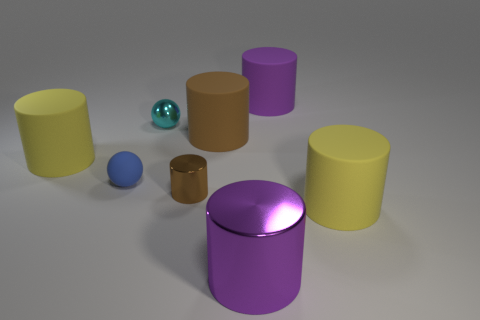Subtract 3 cylinders. How many cylinders are left? 3 Subtract all yellow cylinders. How many cylinders are left? 4 Subtract all brown matte cylinders. How many cylinders are left? 5 Subtract all gray cylinders. Subtract all cyan balls. How many cylinders are left? 6 Add 1 large yellow metal cylinders. How many objects exist? 9 Subtract all cylinders. How many objects are left? 2 Add 1 purple shiny things. How many purple shiny things are left? 2 Add 4 tiny red rubber things. How many tiny red rubber things exist? 4 Subtract 0 red balls. How many objects are left? 8 Subtract all brown rubber balls. Subtract all brown matte things. How many objects are left? 7 